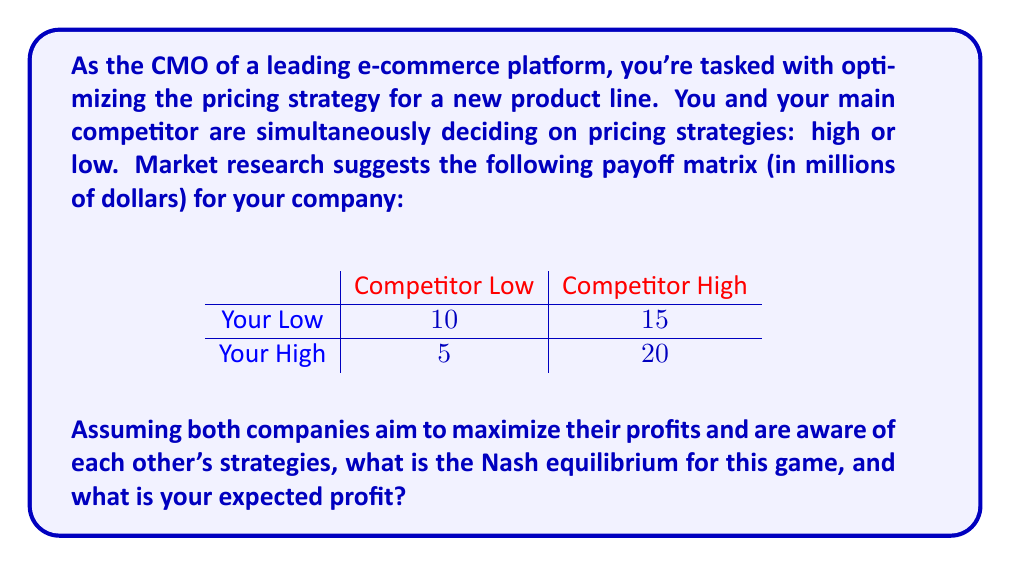What is the answer to this math problem? To solve this problem, we need to find the Nash equilibrium using game theory principles. A Nash equilibrium occurs when neither player can unilaterally change their strategy to increase their payoff.

Let's analyze each possible scenario:

1. If you choose Low:
   - If competitor chooses Low, you get 10
   - If competitor chooses High, you get 15

2. If you choose High:
   - If competitor chooses Low, you get 5
   - If competitor chooses High, you get 20

Now, let's consider the competitor's perspective:

3. If competitor chooses Low:
   - If you choose Low, they get some payoff X
   - If you choose High, they get some payoff Y

4. If competitor chooses High:
   - If you choose Low, they get some payoff Z
   - If you choose High, they get some payoff W

To find the Nash equilibrium, we need to identify a strategy pair where neither player has an incentive to change their strategy.

In this case, we can see that:
- If the competitor chooses Low, your best response is Low (10 > 5)
- If the competitor chooses High, your best response is High (20 > 15)

This indicates that there is no pure strategy Nash equilibrium, as there's no single strategy that's always best for either player.

In such cases, we look for a mixed strategy Nash equilibrium. Let's say you choose Low with probability $p$ and High with probability $(1-p)$.

For the competitor to be indifferent between their strategies (which is necessary for a mixed strategy equilibrium), we set up the equation:

$$10p + 5(1-p) = 15p + 20(1-p)$$

Solving this equation:

$$10p + 5 - 5p = 15p + 20 - 20p$$
$$5p + 5 = -5p + 20$$
$$10p = 15$$
$$p = \frac{3}{2}$$

Since $p$ represents a probability, it must be between 0 and 1. The solution $p = \frac{3}{2}$ is outside this range, which confirms that there is no mixed strategy Nash equilibrium either.

In this case, the Nash equilibrium is actually a pure strategy: (Your Low, Competitor High). This is because:
1. Given the competitor chooses High, your best response is Low (15 > 20)
2. Given you choose Low, the competitor's best response is High (assuming Z > X in their payoff matrix)

Therefore, the Nash equilibrium is (Your Low, Competitor High), and your expected profit is $15 million.
Answer: The Nash equilibrium is (Your Low, Competitor High), and your expected profit is $15 million. 